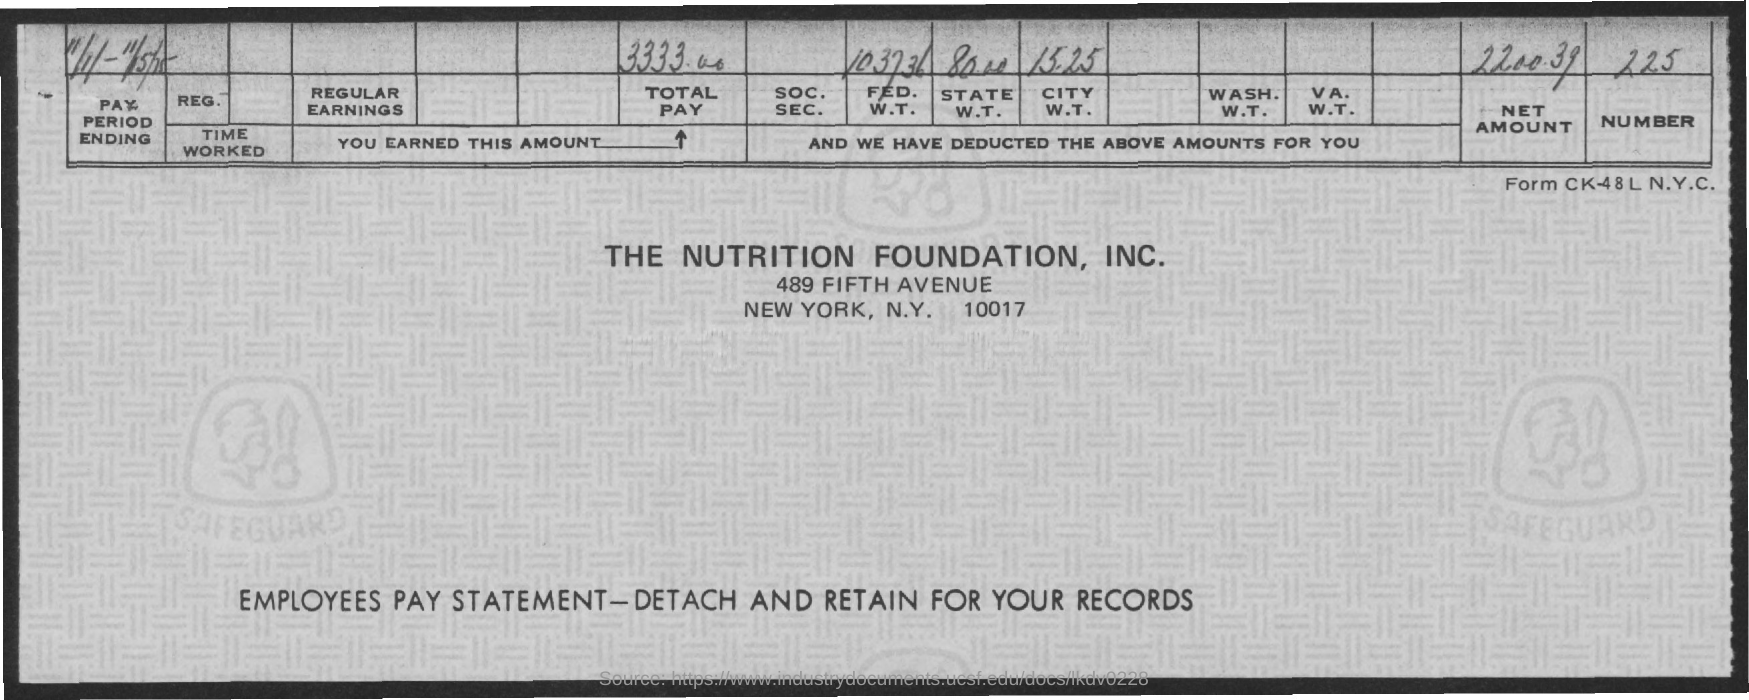Highlight a few significant elements in this photo. The total pay mentioned in the document is 3,333.00. The net amount mentioned in this document is 2,200.39 cents. 